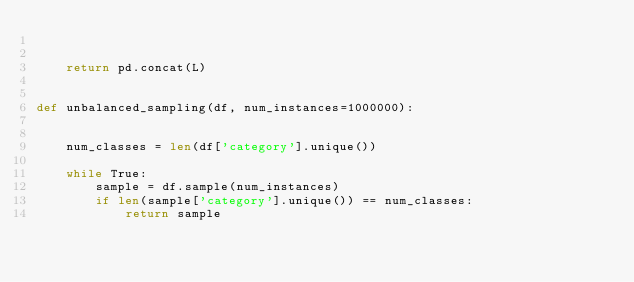Convert code to text. <code><loc_0><loc_0><loc_500><loc_500><_Python_>

    return pd.concat(L)


def unbalanced_sampling(df, num_instances=1000000):


    num_classes = len(df['category'].unique())
    
    while True:
        sample = df.sample(num_instances)
        if len(sample['category'].unique()) == num_classes:
            return sample
    
    </code> 